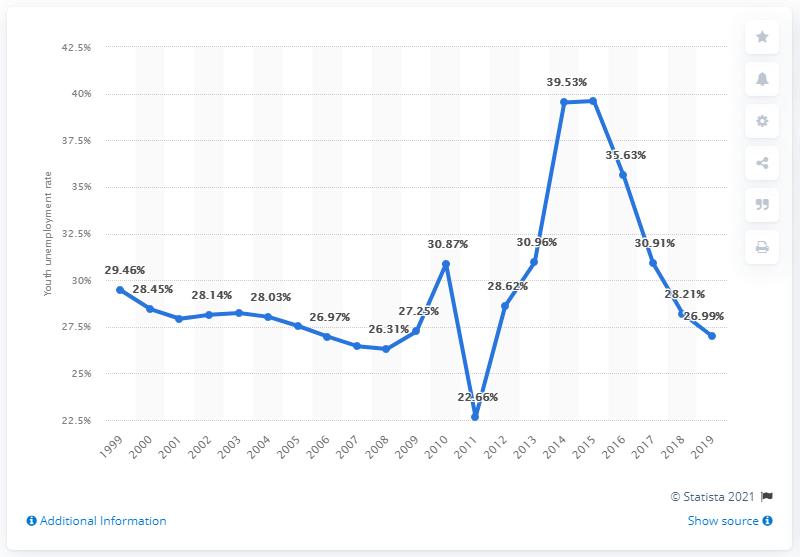Specify some key components in this picture. In 2019, the youth unemployment rate in Albania was 26.99%. 